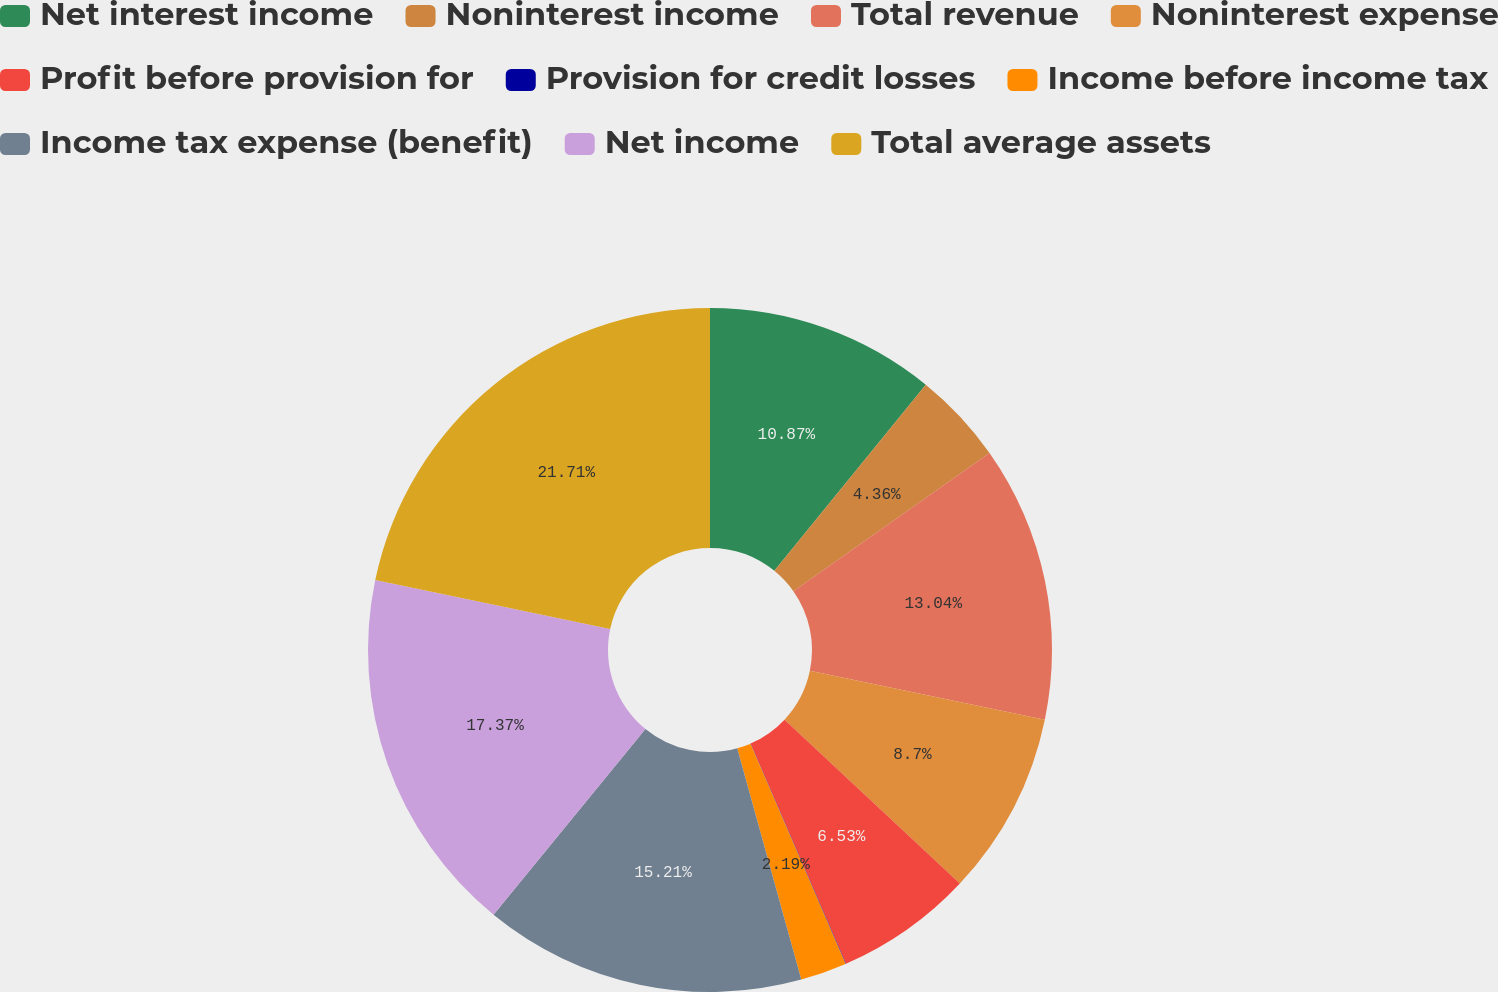Convert chart to OTSL. <chart><loc_0><loc_0><loc_500><loc_500><pie_chart><fcel>Net interest income<fcel>Noninterest income<fcel>Total revenue<fcel>Noninterest expense<fcel>Profit before provision for<fcel>Provision for credit losses<fcel>Income before income tax<fcel>Income tax expense (benefit)<fcel>Net income<fcel>Total average assets<nl><fcel>10.87%<fcel>4.36%<fcel>13.04%<fcel>8.7%<fcel>6.53%<fcel>0.02%<fcel>2.19%<fcel>15.21%<fcel>17.38%<fcel>21.72%<nl></chart> 